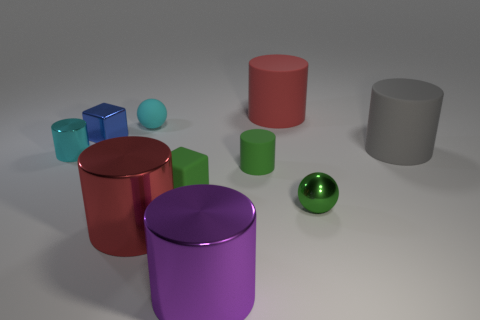Is there any other thing that is the same shape as the red metallic object?
Your answer should be very brief. Yes. There is a thing that is the same color as the tiny shiny cylinder; what is its material?
Ensure brevity in your answer.  Rubber. Are there an equal number of large red cylinders that are in front of the blue metal thing and tiny green cubes?
Offer a very short reply. Yes. Are there any matte blocks to the left of the metallic sphere?
Provide a short and direct response. Yes. There is a gray thing; is it the same shape as the big red thing that is in front of the small shiny ball?
Your response must be concise. Yes. What is the color of the small ball that is the same material as the small blue block?
Ensure brevity in your answer.  Green. What is the color of the small shiny cylinder?
Provide a short and direct response. Cyan. Do the small green sphere and the red object behind the small cyan metallic cylinder have the same material?
Your answer should be compact. No. How many metal cylinders are on the left side of the small green cube and right of the small metal cube?
Keep it short and to the point. 1. There is a green shiny object that is the same size as the cyan ball; what shape is it?
Provide a succinct answer. Sphere. 